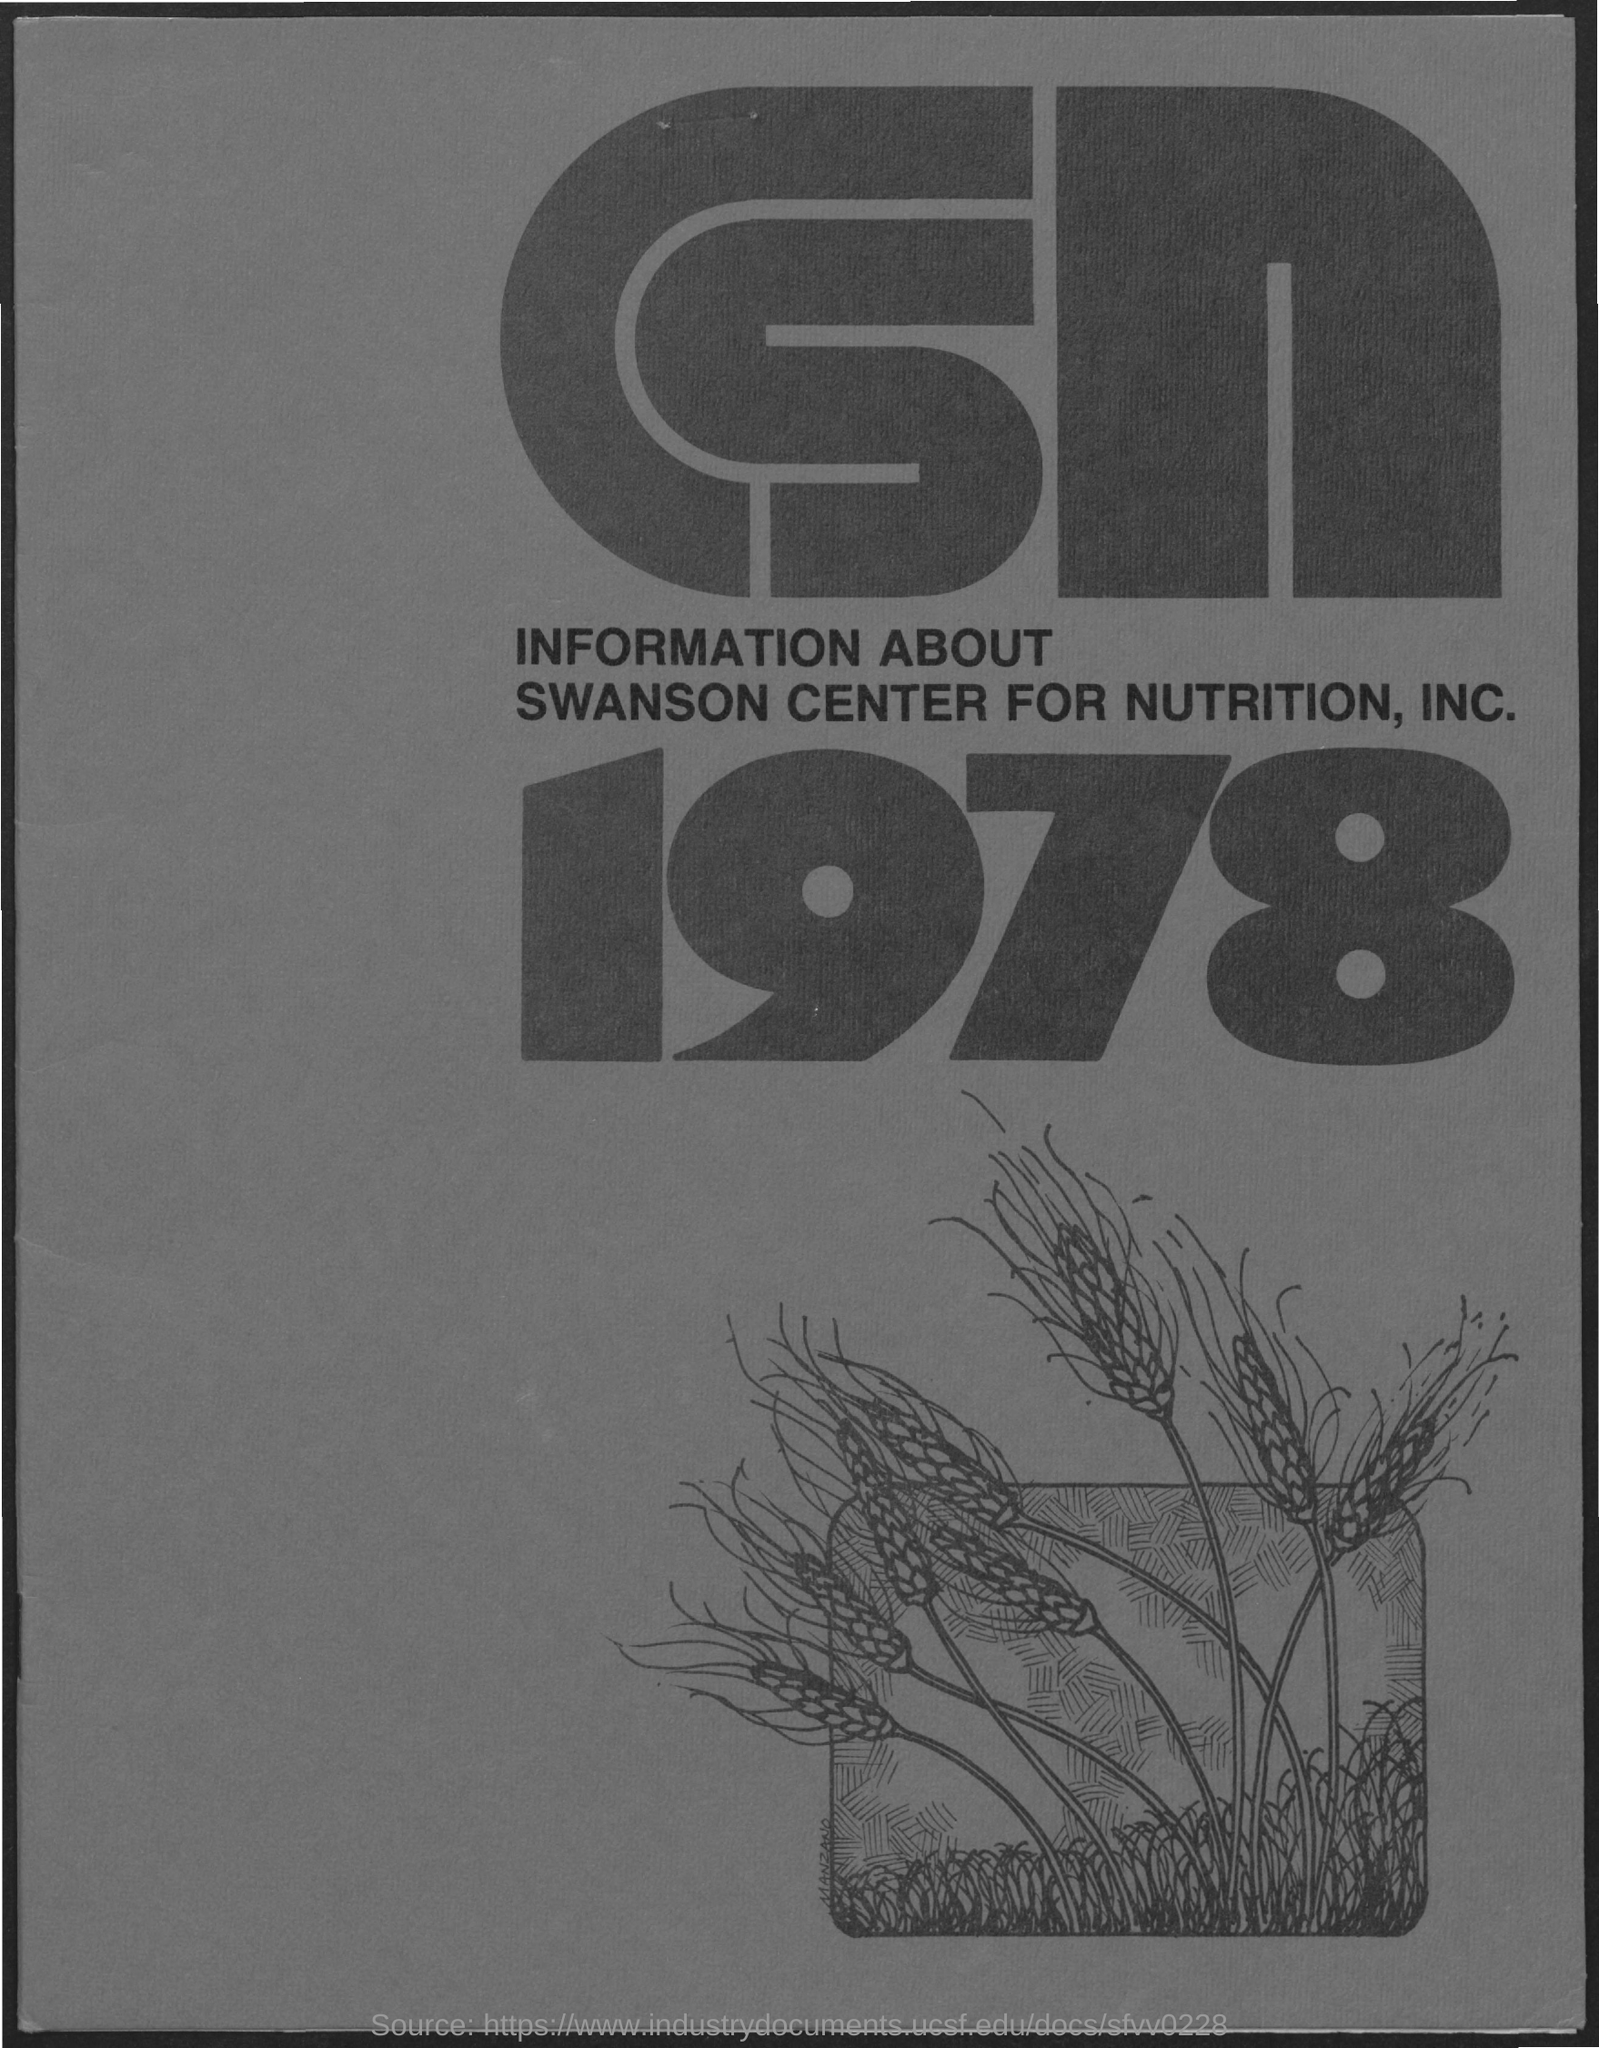Point out several critical features in this image. The Swanson Center for Nutrition, Inc. is a company that provides information about various topics related to nutrition. What is the year? It is 1978. 